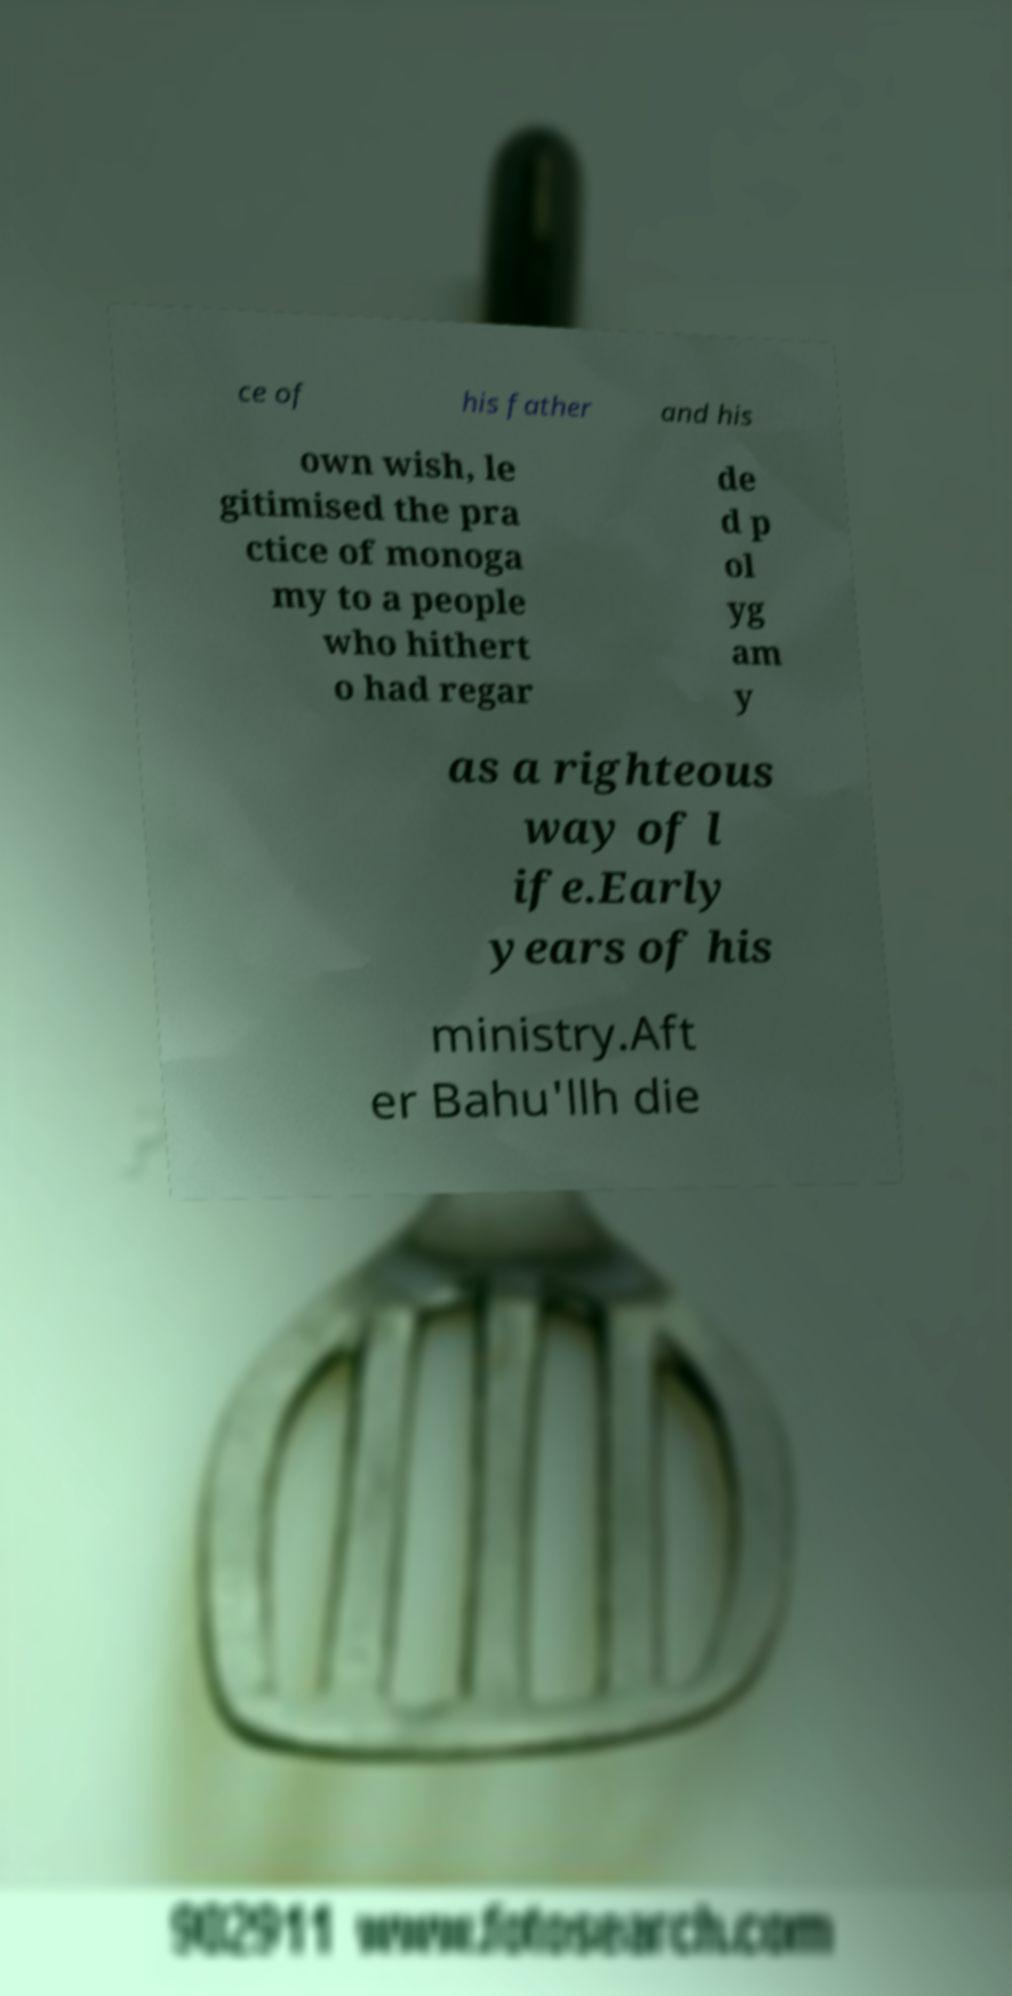Please identify and transcribe the text found in this image. ce of his father and his own wish, le gitimised the pra ctice of monoga my to a people who hithert o had regar de d p ol yg am y as a righteous way of l ife.Early years of his ministry.Aft er Bahu'llh die 